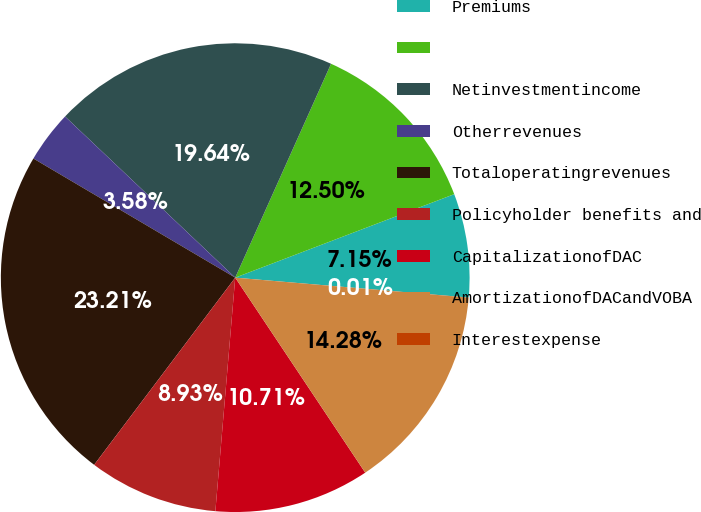Convert chart. <chart><loc_0><loc_0><loc_500><loc_500><pie_chart><fcel>Premiums<fcel>Unnamed: 1<fcel>Netinvestmentincome<fcel>Otherrevenues<fcel>Totaloperatingrevenues<fcel>Policyholder benefits and<fcel>CapitalizationofDAC<fcel>AmortizationofDACandVOBA<fcel>Interestexpense<nl><fcel>7.15%<fcel>12.5%<fcel>19.64%<fcel>3.58%<fcel>23.21%<fcel>8.93%<fcel>10.71%<fcel>14.28%<fcel>0.01%<nl></chart> 